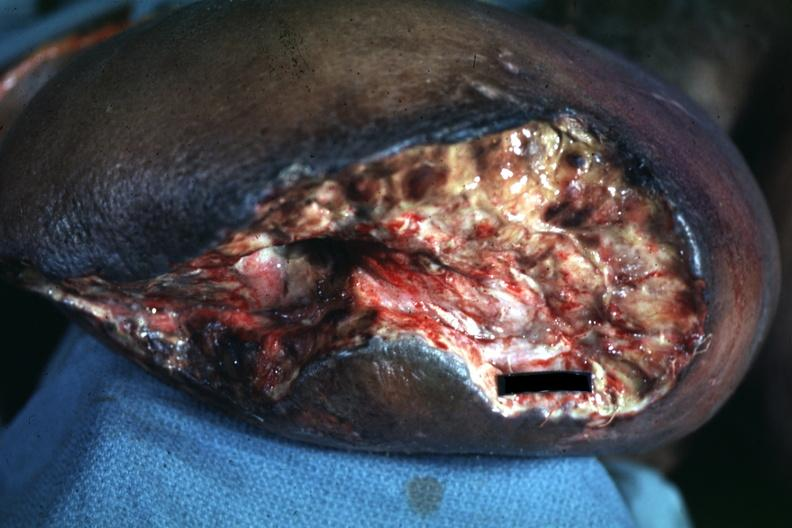does this image show open nasty looking wound appears to be mid thigh?
Answer the question using a single word or phrase. Yes 